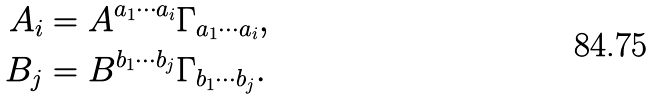Convert formula to latex. <formula><loc_0><loc_0><loc_500><loc_500>A _ { i } & = A ^ { a _ { 1 } \cdots a _ { i } } \Gamma _ { a _ { 1 } \cdots a _ { i } } , \\ B _ { j } & = B ^ { b _ { 1 } \cdots b _ { j } } \Gamma _ { b _ { 1 } \cdots b _ { j } } .</formula> 